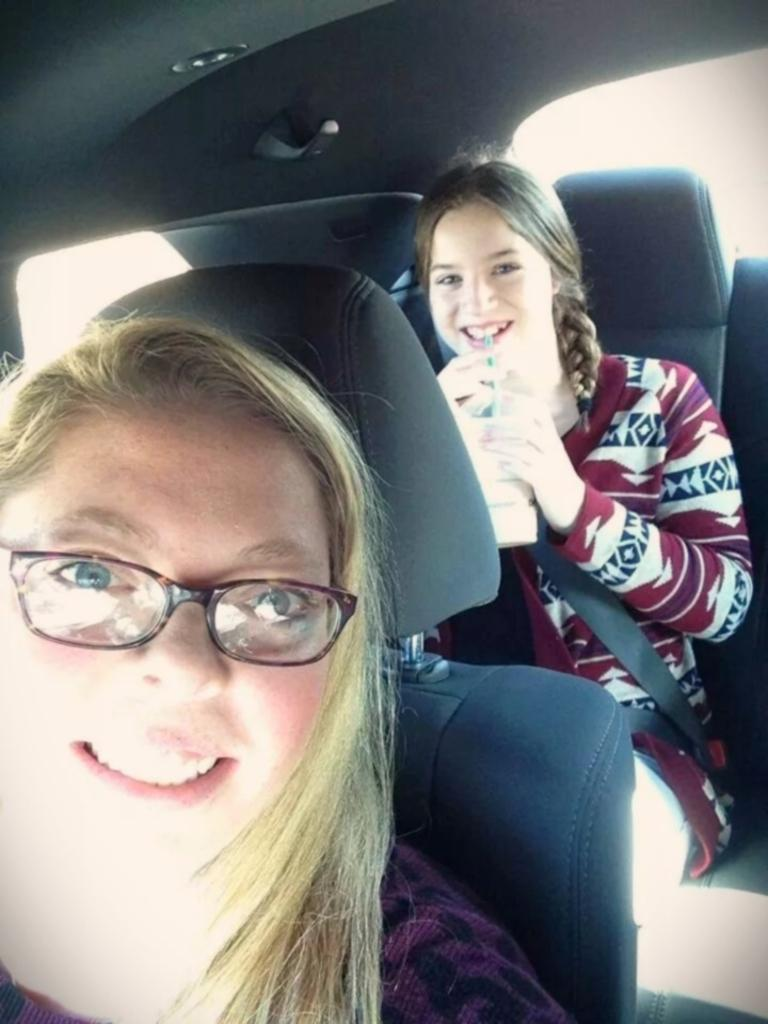How many people are in the image? There are two women in the image. What are the women doing in the image? The women are sitting inside a car. What is the facial expression of the women in the image? The women are smiling. What type of toe is visible in the image? There are no toes visible in the image; it features two women sitting inside a car. How does the car get fuel in the image? The image does not show the car getting fuel, so it cannot be determined from the image. 